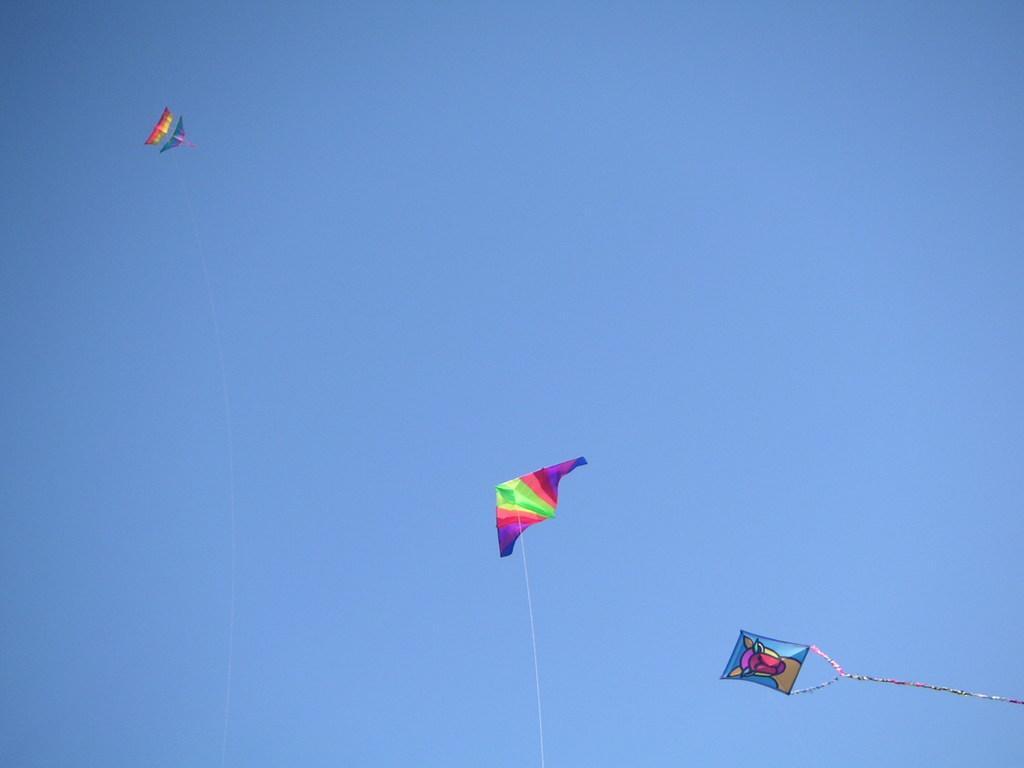In one or two sentences, can you explain what this image depicts? In this image we can see the kites with the threads. In the background we can see the sky. 